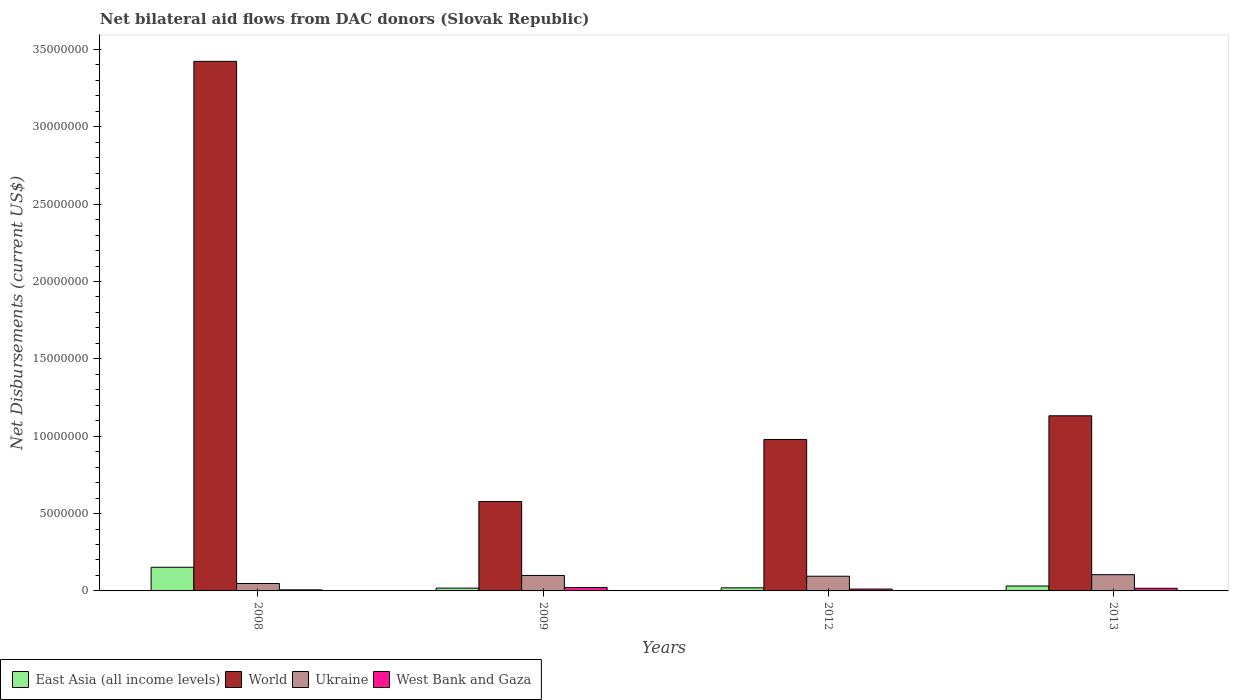How many groups of bars are there?
Your answer should be very brief. 4. Are the number of bars per tick equal to the number of legend labels?
Ensure brevity in your answer.  Yes. Are the number of bars on each tick of the X-axis equal?
Ensure brevity in your answer.  Yes. How many bars are there on the 4th tick from the right?
Ensure brevity in your answer.  4. In how many cases, is the number of bars for a given year not equal to the number of legend labels?
Give a very brief answer. 0. What is the net bilateral aid flows in Ukraine in 2012?
Your answer should be very brief. 9.50e+05. Across all years, what is the maximum net bilateral aid flows in World?
Ensure brevity in your answer.  3.42e+07. Across all years, what is the minimum net bilateral aid flows in World?
Provide a succinct answer. 5.78e+06. In which year was the net bilateral aid flows in Ukraine minimum?
Give a very brief answer. 2008. What is the total net bilateral aid flows in Ukraine in the graph?
Offer a terse response. 3.48e+06. What is the difference between the net bilateral aid flows in Ukraine in 2012 and that in 2013?
Your answer should be compact. -1.00e+05. What is the average net bilateral aid flows in East Asia (all income levels) per year?
Your response must be concise. 5.58e+05. In the year 2008, what is the difference between the net bilateral aid flows in Ukraine and net bilateral aid flows in West Bank and Gaza?
Your answer should be very brief. 4.10e+05. What is the ratio of the net bilateral aid flows in West Bank and Gaza in 2012 to that in 2013?
Provide a short and direct response. 0.71. What is the difference between the highest and the second highest net bilateral aid flows in World?
Offer a very short reply. 2.29e+07. What is the difference between the highest and the lowest net bilateral aid flows in West Bank and Gaza?
Offer a terse response. 1.50e+05. Is the sum of the net bilateral aid flows in East Asia (all income levels) in 2008 and 2012 greater than the maximum net bilateral aid flows in World across all years?
Ensure brevity in your answer.  No. Is it the case that in every year, the sum of the net bilateral aid flows in World and net bilateral aid flows in West Bank and Gaza is greater than the sum of net bilateral aid flows in East Asia (all income levels) and net bilateral aid flows in Ukraine?
Your response must be concise. Yes. What does the 2nd bar from the right in 2013 represents?
Provide a short and direct response. Ukraine. Is it the case that in every year, the sum of the net bilateral aid flows in West Bank and Gaza and net bilateral aid flows in Ukraine is greater than the net bilateral aid flows in East Asia (all income levels)?
Offer a terse response. No. How many bars are there?
Ensure brevity in your answer.  16. Are all the bars in the graph horizontal?
Give a very brief answer. No. Does the graph contain any zero values?
Offer a very short reply. No. How many legend labels are there?
Offer a very short reply. 4. How are the legend labels stacked?
Offer a terse response. Horizontal. What is the title of the graph?
Ensure brevity in your answer.  Net bilateral aid flows from DAC donors (Slovak Republic). What is the label or title of the X-axis?
Make the answer very short. Years. What is the label or title of the Y-axis?
Ensure brevity in your answer.  Net Disbursements (current US$). What is the Net Disbursements (current US$) of East Asia (all income levels) in 2008?
Provide a succinct answer. 1.53e+06. What is the Net Disbursements (current US$) in World in 2008?
Provide a short and direct response. 3.42e+07. What is the Net Disbursements (current US$) of Ukraine in 2008?
Provide a succinct answer. 4.80e+05. What is the Net Disbursements (current US$) in World in 2009?
Your answer should be compact. 5.78e+06. What is the Net Disbursements (current US$) of West Bank and Gaza in 2009?
Your answer should be compact. 2.20e+05. What is the Net Disbursements (current US$) of East Asia (all income levels) in 2012?
Make the answer very short. 2.00e+05. What is the Net Disbursements (current US$) in World in 2012?
Provide a short and direct response. 9.79e+06. What is the Net Disbursements (current US$) of Ukraine in 2012?
Ensure brevity in your answer.  9.50e+05. What is the Net Disbursements (current US$) of West Bank and Gaza in 2012?
Provide a short and direct response. 1.20e+05. What is the Net Disbursements (current US$) of East Asia (all income levels) in 2013?
Offer a very short reply. 3.20e+05. What is the Net Disbursements (current US$) in World in 2013?
Keep it short and to the point. 1.13e+07. What is the Net Disbursements (current US$) of Ukraine in 2013?
Give a very brief answer. 1.05e+06. What is the Net Disbursements (current US$) of West Bank and Gaza in 2013?
Ensure brevity in your answer.  1.70e+05. Across all years, what is the maximum Net Disbursements (current US$) in East Asia (all income levels)?
Your answer should be compact. 1.53e+06. Across all years, what is the maximum Net Disbursements (current US$) of World?
Make the answer very short. 3.42e+07. Across all years, what is the maximum Net Disbursements (current US$) in Ukraine?
Offer a terse response. 1.05e+06. Across all years, what is the minimum Net Disbursements (current US$) of East Asia (all income levels)?
Your answer should be compact. 1.80e+05. Across all years, what is the minimum Net Disbursements (current US$) in World?
Make the answer very short. 5.78e+06. What is the total Net Disbursements (current US$) of East Asia (all income levels) in the graph?
Provide a succinct answer. 2.23e+06. What is the total Net Disbursements (current US$) of World in the graph?
Your response must be concise. 6.11e+07. What is the total Net Disbursements (current US$) in Ukraine in the graph?
Offer a very short reply. 3.48e+06. What is the total Net Disbursements (current US$) of West Bank and Gaza in the graph?
Keep it short and to the point. 5.80e+05. What is the difference between the Net Disbursements (current US$) of East Asia (all income levels) in 2008 and that in 2009?
Provide a succinct answer. 1.35e+06. What is the difference between the Net Disbursements (current US$) in World in 2008 and that in 2009?
Provide a short and direct response. 2.84e+07. What is the difference between the Net Disbursements (current US$) in Ukraine in 2008 and that in 2009?
Ensure brevity in your answer.  -5.20e+05. What is the difference between the Net Disbursements (current US$) in East Asia (all income levels) in 2008 and that in 2012?
Ensure brevity in your answer.  1.33e+06. What is the difference between the Net Disbursements (current US$) in World in 2008 and that in 2012?
Your response must be concise. 2.44e+07. What is the difference between the Net Disbursements (current US$) of Ukraine in 2008 and that in 2012?
Your answer should be very brief. -4.70e+05. What is the difference between the Net Disbursements (current US$) of West Bank and Gaza in 2008 and that in 2012?
Your answer should be compact. -5.00e+04. What is the difference between the Net Disbursements (current US$) in East Asia (all income levels) in 2008 and that in 2013?
Provide a short and direct response. 1.21e+06. What is the difference between the Net Disbursements (current US$) of World in 2008 and that in 2013?
Make the answer very short. 2.29e+07. What is the difference between the Net Disbursements (current US$) in Ukraine in 2008 and that in 2013?
Provide a short and direct response. -5.70e+05. What is the difference between the Net Disbursements (current US$) of West Bank and Gaza in 2008 and that in 2013?
Keep it short and to the point. -1.00e+05. What is the difference between the Net Disbursements (current US$) of East Asia (all income levels) in 2009 and that in 2012?
Offer a terse response. -2.00e+04. What is the difference between the Net Disbursements (current US$) in World in 2009 and that in 2012?
Offer a terse response. -4.01e+06. What is the difference between the Net Disbursements (current US$) of East Asia (all income levels) in 2009 and that in 2013?
Your answer should be very brief. -1.40e+05. What is the difference between the Net Disbursements (current US$) of World in 2009 and that in 2013?
Offer a very short reply. -5.54e+06. What is the difference between the Net Disbursements (current US$) in Ukraine in 2009 and that in 2013?
Make the answer very short. -5.00e+04. What is the difference between the Net Disbursements (current US$) in World in 2012 and that in 2013?
Give a very brief answer. -1.53e+06. What is the difference between the Net Disbursements (current US$) in West Bank and Gaza in 2012 and that in 2013?
Your answer should be compact. -5.00e+04. What is the difference between the Net Disbursements (current US$) in East Asia (all income levels) in 2008 and the Net Disbursements (current US$) in World in 2009?
Your response must be concise. -4.25e+06. What is the difference between the Net Disbursements (current US$) of East Asia (all income levels) in 2008 and the Net Disbursements (current US$) of Ukraine in 2009?
Your response must be concise. 5.30e+05. What is the difference between the Net Disbursements (current US$) in East Asia (all income levels) in 2008 and the Net Disbursements (current US$) in West Bank and Gaza in 2009?
Give a very brief answer. 1.31e+06. What is the difference between the Net Disbursements (current US$) in World in 2008 and the Net Disbursements (current US$) in Ukraine in 2009?
Offer a very short reply. 3.32e+07. What is the difference between the Net Disbursements (current US$) in World in 2008 and the Net Disbursements (current US$) in West Bank and Gaza in 2009?
Give a very brief answer. 3.40e+07. What is the difference between the Net Disbursements (current US$) of East Asia (all income levels) in 2008 and the Net Disbursements (current US$) of World in 2012?
Provide a short and direct response. -8.26e+06. What is the difference between the Net Disbursements (current US$) in East Asia (all income levels) in 2008 and the Net Disbursements (current US$) in Ukraine in 2012?
Ensure brevity in your answer.  5.80e+05. What is the difference between the Net Disbursements (current US$) of East Asia (all income levels) in 2008 and the Net Disbursements (current US$) of West Bank and Gaza in 2012?
Your answer should be compact. 1.41e+06. What is the difference between the Net Disbursements (current US$) of World in 2008 and the Net Disbursements (current US$) of Ukraine in 2012?
Your answer should be very brief. 3.33e+07. What is the difference between the Net Disbursements (current US$) in World in 2008 and the Net Disbursements (current US$) in West Bank and Gaza in 2012?
Keep it short and to the point. 3.41e+07. What is the difference between the Net Disbursements (current US$) of East Asia (all income levels) in 2008 and the Net Disbursements (current US$) of World in 2013?
Ensure brevity in your answer.  -9.79e+06. What is the difference between the Net Disbursements (current US$) in East Asia (all income levels) in 2008 and the Net Disbursements (current US$) in Ukraine in 2013?
Give a very brief answer. 4.80e+05. What is the difference between the Net Disbursements (current US$) of East Asia (all income levels) in 2008 and the Net Disbursements (current US$) of West Bank and Gaza in 2013?
Provide a short and direct response. 1.36e+06. What is the difference between the Net Disbursements (current US$) in World in 2008 and the Net Disbursements (current US$) in Ukraine in 2013?
Provide a short and direct response. 3.32e+07. What is the difference between the Net Disbursements (current US$) in World in 2008 and the Net Disbursements (current US$) in West Bank and Gaza in 2013?
Your answer should be compact. 3.41e+07. What is the difference between the Net Disbursements (current US$) in Ukraine in 2008 and the Net Disbursements (current US$) in West Bank and Gaza in 2013?
Your response must be concise. 3.10e+05. What is the difference between the Net Disbursements (current US$) of East Asia (all income levels) in 2009 and the Net Disbursements (current US$) of World in 2012?
Your answer should be very brief. -9.61e+06. What is the difference between the Net Disbursements (current US$) of East Asia (all income levels) in 2009 and the Net Disbursements (current US$) of Ukraine in 2012?
Provide a short and direct response. -7.70e+05. What is the difference between the Net Disbursements (current US$) in World in 2009 and the Net Disbursements (current US$) in Ukraine in 2012?
Make the answer very short. 4.83e+06. What is the difference between the Net Disbursements (current US$) of World in 2009 and the Net Disbursements (current US$) of West Bank and Gaza in 2012?
Your answer should be very brief. 5.66e+06. What is the difference between the Net Disbursements (current US$) of Ukraine in 2009 and the Net Disbursements (current US$) of West Bank and Gaza in 2012?
Give a very brief answer. 8.80e+05. What is the difference between the Net Disbursements (current US$) in East Asia (all income levels) in 2009 and the Net Disbursements (current US$) in World in 2013?
Your answer should be compact. -1.11e+07. What is the difference between the Net Disbursements (current US$) in East Asia (all income levels) in 2009 and the Net Disbursements (current US$) in Ukraine in 2013?
Give a very brief answer. -8.70e+05. What is the difference between the Net Disbursements (current US$) of East Asia (all income levels) in 2009 and the Net Disbursements (current US$) of West Bank and Gaza in 2013?
Your response must be concise. 10000. What is the difference between the Net Disbursements (current US$) in World in 2009 and the Net Disbursements (current US$) in Ukraine in 2013?
Your answer should be very brief. 4.73e+06. What is the difference between the Net Disbursements (current US$) in World in 2009 and the Net Disbursements (current US$) in West Bank and Gaza in 2013?
Provide a short and direct response. 5.61e+06. What is the difference between the Net Disbursements (current US$) in Ukraine in 2009 and the Net Disbursements (current US$) in West Bank and Gaza in 2013?
Keep it short and to the point. 8.30e+05. What is the difference between the Net Disbursements (current US$) of East Asia (all income levels) in 2012 and the Net Disbursements (current US$) of World in 2013?
Offer a very short reply. -1.11e+07. What is the difference between the Net Disbursements (current US$) of East Asia (all income levels) in 2012 and the Net Disbursements (current US$) of Ukraine in 2013?
Offer a terse response. -8.50e+05. What is the difference between the Net Disbursements (current US$) in East Asia (all income levels) in 2012 and the Net Disbursements (current US$) in West Bank and Gaza in 2013?
Make the answer very short. 3.00e+04. What is the difference between the Net Disbursements (current US$) in World in 2012 and the Net Disbursements (current US$) in Ukraine in 2013?
Keep it short and to the point. 8.74e+06. What is the difference between the Net Disbursements (current US$) of World in 2012 and the Net Disbursements (current US$) of West Bank and Gaza in 2013?
Provide a short and direct response. 9.62e+06. What is the difference between the Net Disbursements (current US$) of Ukraine in 2012 and the Net Disbursements (current US$) of West Bank and Gaza in 2013?
Give a very brief answer. 7.80e+05. What is the average Net Disbursements (current US$) in East Asia (all income levels) per year?
Offer a very short reply. 5.58e+05. What is the average Net Disbursements (current US$) of World per year?
Make the answer very short. 1.53e+07. What is the average Net Disbursements (current US$) in Ukraine per year?
Ensure brevity in your answer.  8.70e+05. What is the average Net Disbursements (current US$) of West Bank and Gaza per year?
Provide a succinct answer. 1.45e+05. In the year 2008, what is the difference between the Net Disbursements (current US$) of East Asia (all income levels) and Net Disbursements (current US$) of World?
Ensure brevity in your answer.  -3.27e+07. In the year 2008, what is the difference between the Net Disbursements (current US$) of East Asia (all income levels) and Net Disbursements (current US$) of Ukraine?
Give a very brief answer. 1.05e+06. In the year 2008, what is the difference between the Net Disbursements (current US$) in East Asia (all income levels) and Net Disbursements (current US$) in West Bank and Gaza?
Give a very brief answer. 1.46e+06. In the year 2008, what is the difference between the Net Disbursements (current US$) of World and Net Disbursements (current US$) of Ukraine?
Provide a short and direct response. 3.38e+07. In the year 2008, what is the difference between the Net Disbursements (current US$) in World and Net Disbursements (current US$) in West Bank and Gaza?
Your response must be concise. 3.42e+07. In the year 2009, what is the difference between the Net Disbursements (current US$) of East Asia (all income levels) and Net Disbursements (current US$) of World?
Offer a terse response. -5.60e+06. In the year 2009, what is the difference between the Net Disbursements (current US$) in East Asia (all income levels) and Net Disbursements (current US$) in Ukraine?
Your answer should be compact. -8.20e+05. In the year 2009, what is the difference between the Net Disbursements (current US$) in World and Net Disbursements (current US$) in Ukraine?
Offer a terse response. 4.78e+06. In the year 2009, what is the difference between the Net Disbursements (current US$) in World and Net Disbursements (current US$) in West Bank and Gaza?
Ensure brevity in your answer.  5.56e+06. In the year 2009, what is the difference between the Net Disbursements (current US$) of Ukraine and Net Disbursements (current US$) of West Bank and Gaza?
Keep it short and to the point. 7.80e+05. In the year 2012, what is the difference between the Net Disbursements (current US$) of East Asia (all income levels) and Net Disbursements (current US$) of World?
Provide a succinct answer. -9.59e+06. In the year 2012, what is the difference between the Net Disbursements (current US$) of East Asia (all income levels) and Net Disbursements (current US$) of Ukraine?
Keep it short and to the point. -7.50e+05. In the year 2012, what is the difference between the Net Disbursements (current US$) of World and Net Disbursements (current US$) of Ukraine?
Ensure brevity in your answer.  8.84e+06. In the year 2012, what is the difference between the Net Disbursements (current US$) of World and Net Disbursements (current US$) of West Bank and Gaza?
Provide a succinct answer. 9.67e+06. In the year 2012, what is the difference between the Net Disbursements (current US$) of Ukraine and Net Disbursements (current US$) of West Bank and Gaza?
Offer a very short reply. 8.30e+05. In the year 2013, what is the difference between the Net Disbursements (current US$) of East Asia (all income levels) and Net Disbursements (current US$) of World?
Provide a short and direct response. -1.10e+07. In the year 2013, what is the difference between the Net Disbursements (current US$) of East Asia (all income levels) and Net Disbursements (current US$) of Ukraine?
Offer a terse response. -7.30e+05. In the year 2013, what is the difference between the Net Disbursements (current US$) of East Asia (all income levels) and Net Disbursements (current US$) of West Bank and Gaza?
Offer a very short reply. 1.50e+05. In the year 2013, what is the difference between the Net Disbursements (current US$) in World and Net Disbursements (current US$) in Ukraine?
Your answer should be very brief. 1.03e+07. In the year 2013, what is the difference between the Net Disbursements (current US$) in World and Net Disbursements (current US$) in West Bank and Gaza?
Give a very brief answer. 1.12e+07. In the year 2013, what is the difference between the Net Disbursements (current US$) in Ukraine and Net Disbursements (current US$) in West Bank and Gaza?
Your response must be concise. 8.80e+05. What is the ratio of the Net Disbursements (current US$) of World in 2008 to that in 2009?
Offer a very short reply. 5.92. What is the ratio of the Net Disbursements (current US$) of Ukraine in 2008 to that in 2009?
Provide a succinct answer. 0.48. What is the ratio of the Net Disbursements (current US$) in West Bank and Gaza in 2008 to that in 2009?
Offer a very short reply. 0.32. What is the ratio of the Net Disbursements (current US$) in East Asia (all income levels) in 2008 to that in 2012?
Provide a succinct answer. 7.65. What is the ratio of the Net Disbursements (current US$) in World in 2008 to that in 2012?
Ensure brevity in your answer.  3.5. What is the ratio of the Net Disbursements (current US$) in Ukraine in 2008 to that in 2012?
Give a very brief answer. 0.51. What is the ratio of the Net Disbursements (current US$) of West Bank and Gaza in 2008 to that in 2012?
Offer a very short reply. 0.58. What is the ratio of the Net Disbursements (current US$) of East Asia (all income levels) in 2008 to that in 2013?
Offer a terse response. 4.78. What is the ratio of the Net Disbursements (current US$) of World in 2008 to that in 2013?
Provide a short and direct response. 3.02. What is the ratio of the Net Disbursements (current US$) in Ukraine in 2008 to that in 2013?
Make the answer very short. 0.46. What is the ratio of the Net Disbursements (current US$) of West Bank and Gaza in 2008 to that in 2013?
Offer a terse response. 0.41. What is the ratio of the Net Disbursements (current US$) of East Asia (all income levels) in 2009 to that in 2012?
Your response must be concise. 0.9. What is the ratio of the Net Disbursements (current US$) of World in 2009 to that in 2012?
Your answer should be very brief. 0.59. What is the ratio of the Net Disbursements (current US$) in Ukraine in 2009 to that in 2012?
Offer a very short reply. 1.05. What is the ratio of the Net Disbursements (current US$) of West Bank and Gaza in 2009 to that in 2012?
Keep it short and to the point. 1.83. What is the ratio of the Net Disbursements (current US$) of East Asia (all income levels) in 2009 to that in 2013?
Offer a terse response. 0.56. What is the ratio of the Net Disbursements (current US$) in World in 2009 to that in 2013?
Ensure brevity in your answer.  0.51. What is the ratio of the Net Disbursements (current US$) of Ukraine in 2009 to that in 2013?
Provide a succinct answer. 0.95. What is the ratio of the Net Disbursements (current US$) in West Bank and Gaza in 2009 to that in 2013?
Offer a very short reply. 1.29. What is the ratio of the Net Disbursements (current US$) in East Asia (all income levels) in 2012 to that in 2013?
Your answer should be compact. 0.62. What is the ratio of the Net Disbursements (current US$) of World in 2012 to that in 2013?
Your answer should be compact. 0.86. What is the ratio of the Net Disbursements (current US$) of Ukraine in 2012 to that in 2013?
Provide a short and direct response. 0.9. What is the ratio of the Net Disbursements (current US$) in West Bank and Gaza in 2012 to that in 2013?
Offer a very short reply. 0.71. What is the difference between the highest and the second highest Net Disbursements (current US$) of East Asia (all income levels)?
Offer a very short reply. 1.21e+06. What is the difference between the highest and the second highest Net Disbursements (current US$) of World?
Your answer should be very brief. 2.29e+07. What is the difference between the highest and the lowest Net Disbursements (current US$) of East Asia (all income levels)?
Your response must be concise. 1.35e+06. What is the difference between the highest and the lowest Net Disbursements (current US$) of World?
Keep it short and to the point. 2.84e+07. What is the difference between the highest and the lowest Net Disbursements (current US$) in Ukraine?
Give a very brief answer. 5.70e+05. 